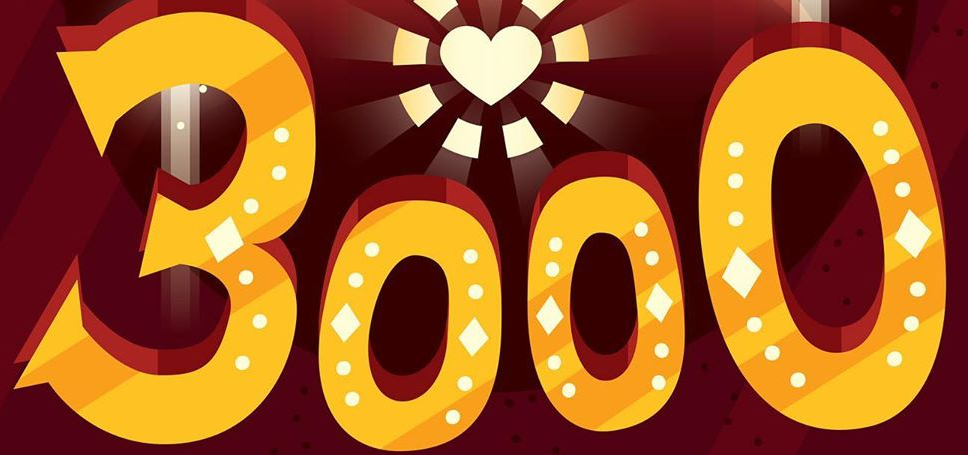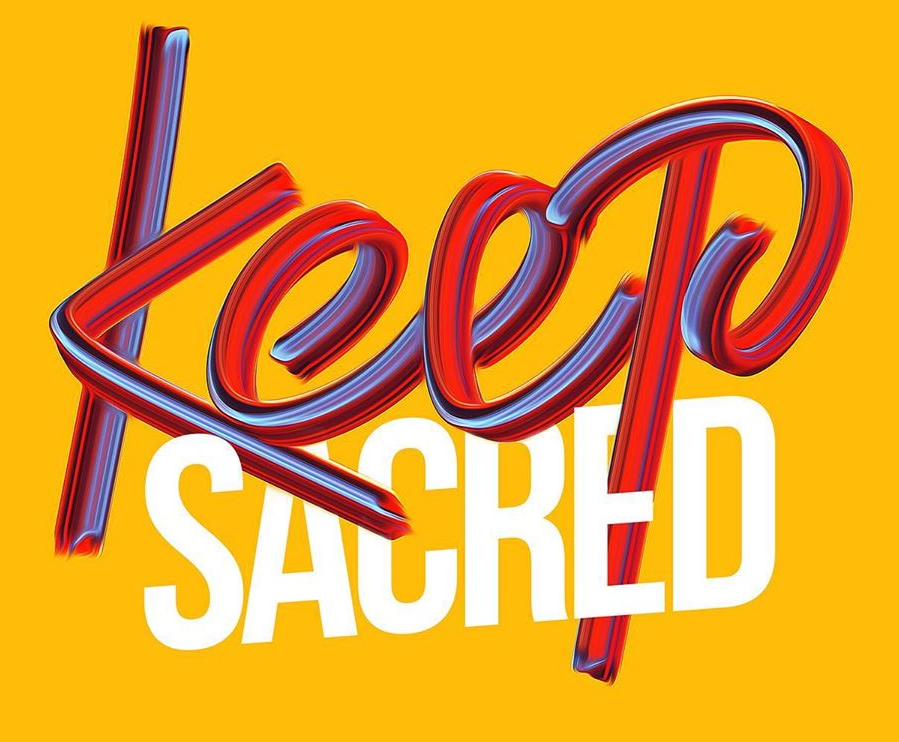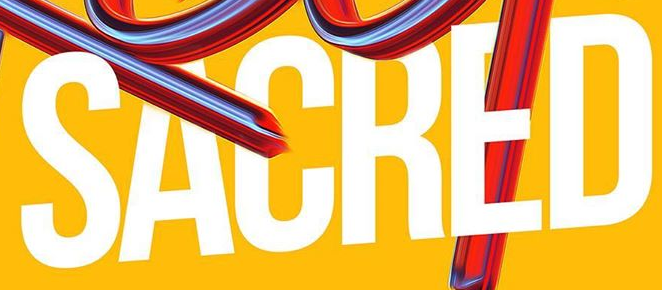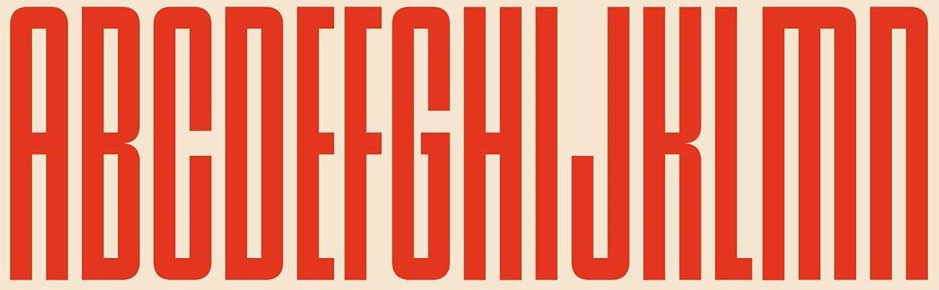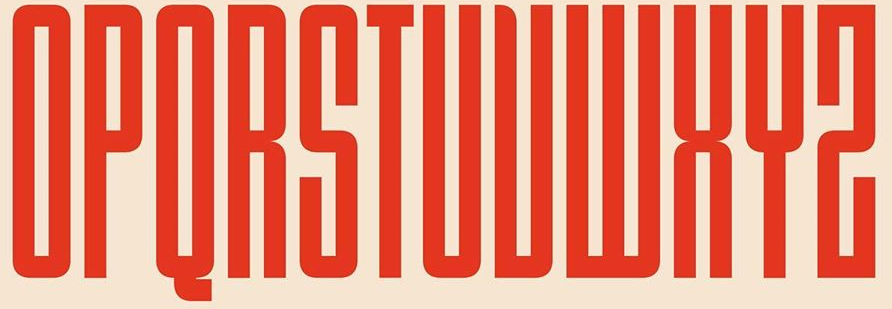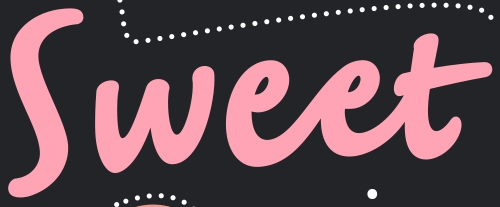What words can you see in these images in sequence, separated by a semicolon? 3000; Keep; SACRED; ABCDEFGHIJKLMN; OPQRSTUVWXYZ; Sweet 